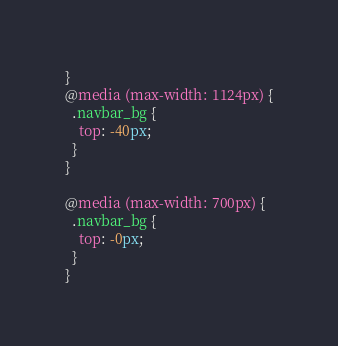Convert code to text. <code><loc_0><loc_0><loc_500><loc_500><_CSS_>}
@media (max-width: 1124px) {
  .navbar_bg {
    top: -40px;
  }
}

@media (max-width: 700px) {
  .navbar_bg {
    top: -0px;
  }
}
</code> 